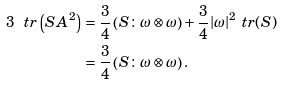<formula> <loc_0><loc_0><loc_500><loc_500>3 \ t r \left ( S A ^ { 2 } \right ) & = \frac { 3 } { 4 } \left ( S \colon \omega \otimes \omega \right ) + \frac { 3 } { 4 } | \omega | ^ { 2 } \ t r ( S ) \\ & = \frac { 3 } { 4 } \left ( S \colon \omega \otimes \omega \right ) .</formula> 